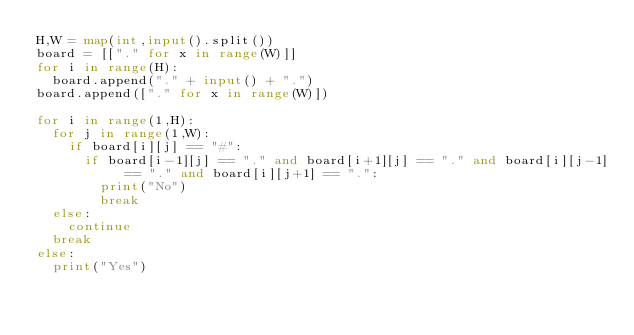Convert code to text. <code><loc_0><loc_0><loc_500><loc_500><_Python_>H,W = map(int,input().split())
board = [["." for x in range(W)]]
for i in range(H):
	board.append("." + input() + ".")
board.append(["." for x in range(W)])

for i in range(1,H):
	for j in range(1,W):
		if board[i][j] == "#":
			if board[i-1][j] == "." and board[i+1][j] == "." and board[i][j-1] == "." and board[i][j+1] == ".":
				print("No")
				break
	else:
		continue
	break
else:
	print("Yes")
</code> 